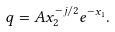Convert formula to latex. <formula><loc_0><loc_0><loc_500><loc_500>q = A x _ { 2 } ^ { - j / 2 } e ^ { - x _ { 1 } } .</formula> 